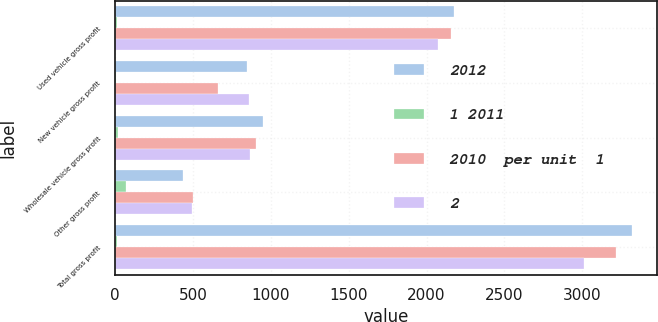Convert chart. <chart><loc_0><loc_0><loc_500><loc_500><stacked_bar_chart><ecel><fcel>Used vehicle gross profit<fcel>New vehicle gross profit<fcel>Wholesale vehicle gross profit<fcel>Other gross profit<fcel>Total gross profit<nl><fcel>2012<fcel>2177<fcel>847<fcel>953<fcel>438<fcel>3316<nl><fcel>1 2011<fcel>11.4<fcel>3.2<fcel>17.5<fcel>71.5<fcel>13.8<nl><fcel>2010  per unit  1<fcel>2156<fcel>659<fcel>908<fcel>502<fcel>3218<nl><fcel>2<fcel>2072<fcel>858<fcel>869<fcel>495<fcel>3011<nl></chart> 